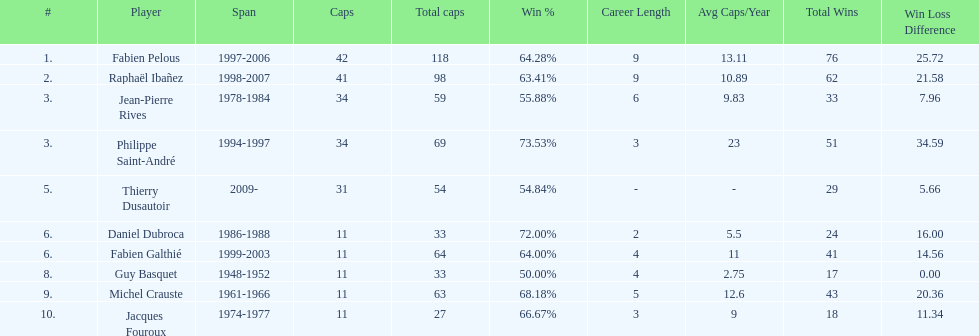Only player to serve as captain from 1998-2007 Raphaël Ibañez. 